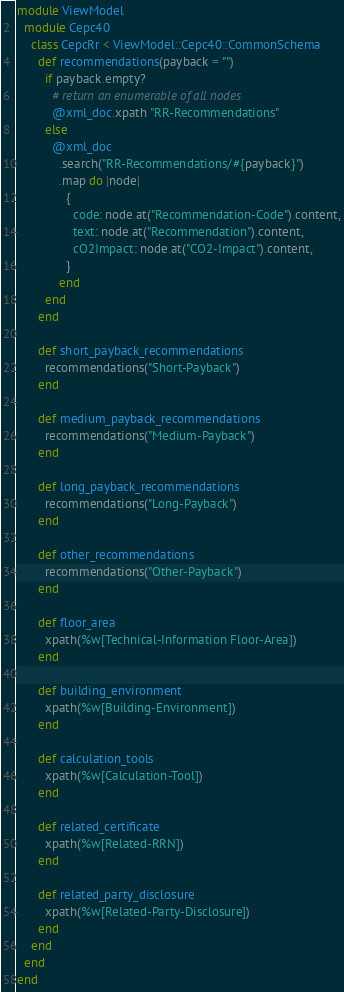<code> <loc_0><loc_0><loc_500><loc_500><_Ruby_>module ViewModel
  module Cepc40
    class CepcRr < ViewModel::Cepc40::CommonSchema
      def recommendations(payback = "")
        if payback.empty?
          # return an enumerable of all nodes
          @xml_doc.xpath "RR-Recommendations"
        else
          @xml_doc
            .search("RR-Recommendations/#{payback}")
            .map do |node|
              {
                code: node.at("Recommendation-Code").content,
                text: node.at("Recommendation").content,
                cO2Impact: node.at("CO2-Impact").content,
              }
            end
        end
      end

      def short_payback_recommendations
        recommendations("Short-Payback")
      end

      def medium_payback_recommendations
        recommendations("Medium-Payback")
      end

      def long_payback_recommendations
        recommendations("Long-Payback")
      end

      def other_recommendations
        recommendations("Other-Payback")
      end

      def floor_area
        xpath(%w[Technical-Information Floor-Area])
      end

      def building_environment
        xpath(%w[Building-Environment])
      end

      def calculation_tools
        xpath(%w[Calculation-Tool])
      end

      def related_certificate
        xpath(%w[Related-RRN])
      end

      def related_party_disclosure
        xpath(%w[Related-Party-Disclosure])
      end
    end
  end
end
</code> 